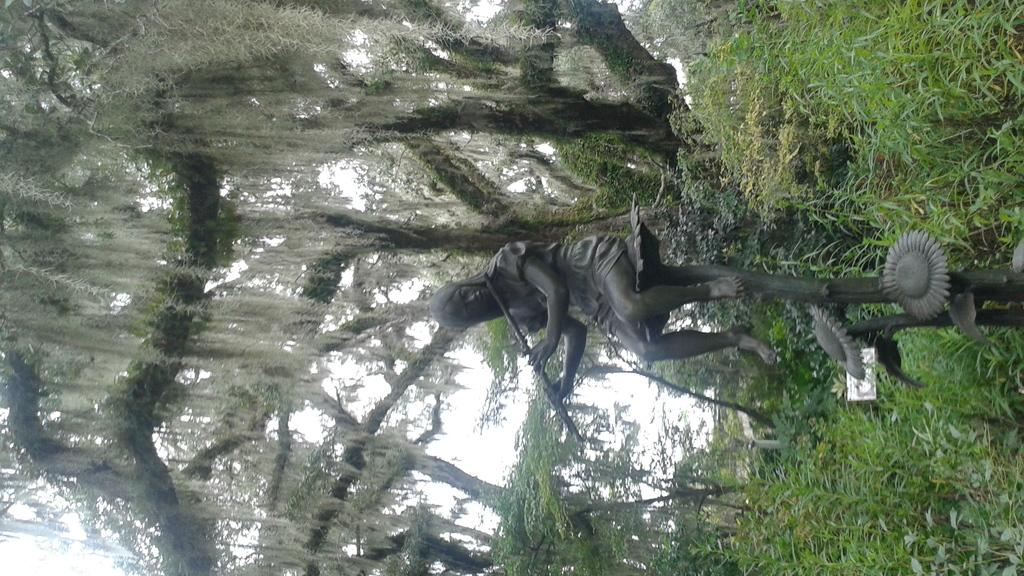What is the main subject in the image? There is a statue in the image. How would you describe the background of the image? The background of the image has a blurred view. What can be seen in the background of the image besides the blurred view? Trees and the sky are visible in the background of the image. What is located on the right side of the image? There are plants and a board on the right side of the image. What type of furniture is being represented by the statue in the image? There is no furniture being represented by the statue in the image; it is a statue and not a representation of any furniture. 